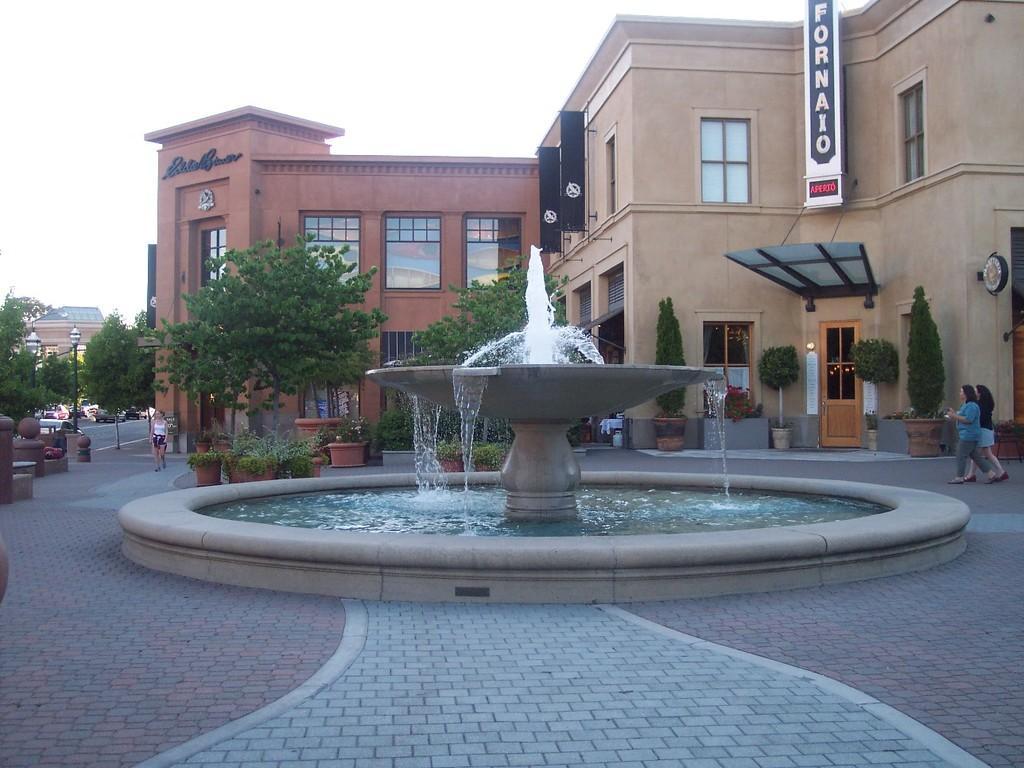Describe this image in one or two sentences. In the picture we can see a huge part on it, we can see a water surface and a fountain with waterfall and behind it, we can see some plants, trees and buildings with windows and glasses in it and in the background we can see a sky. 